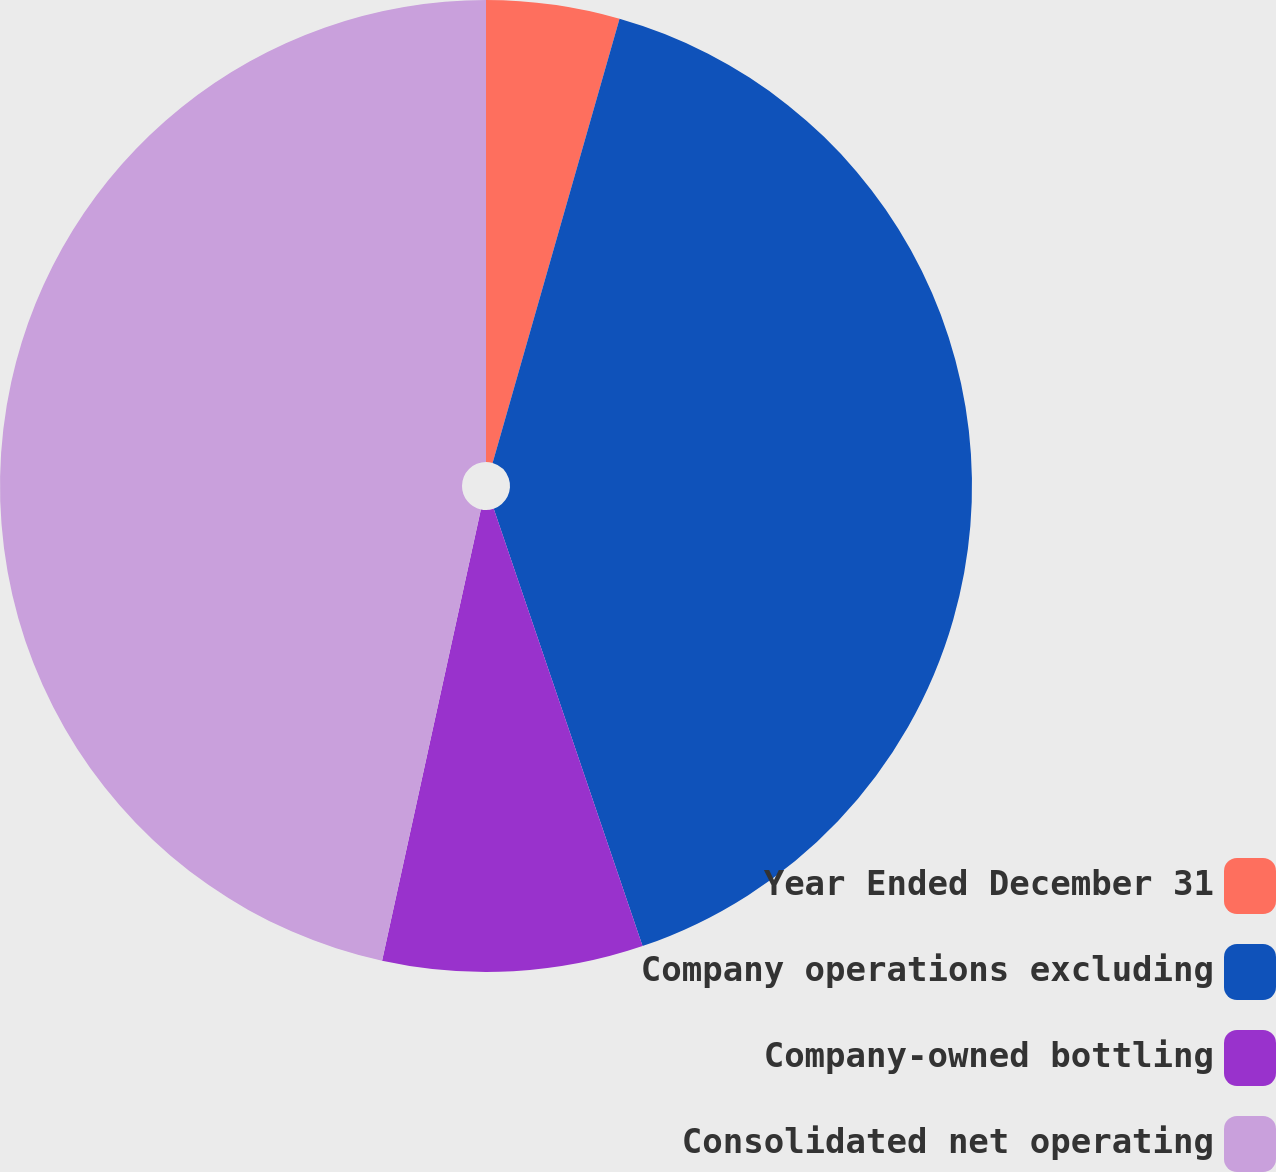<chart> <loc_0><loc_0><loc_500><loc_500><pie_chart><fcel>Year Ended December 31<fcel>Company operations excluding<fcel>Company-owned bottling<fcel>Consolidated net operating<nl><fcel>4.43%<fcel>40.35%<fcel>8.65%<fcel>46.57%<nl></chart> 